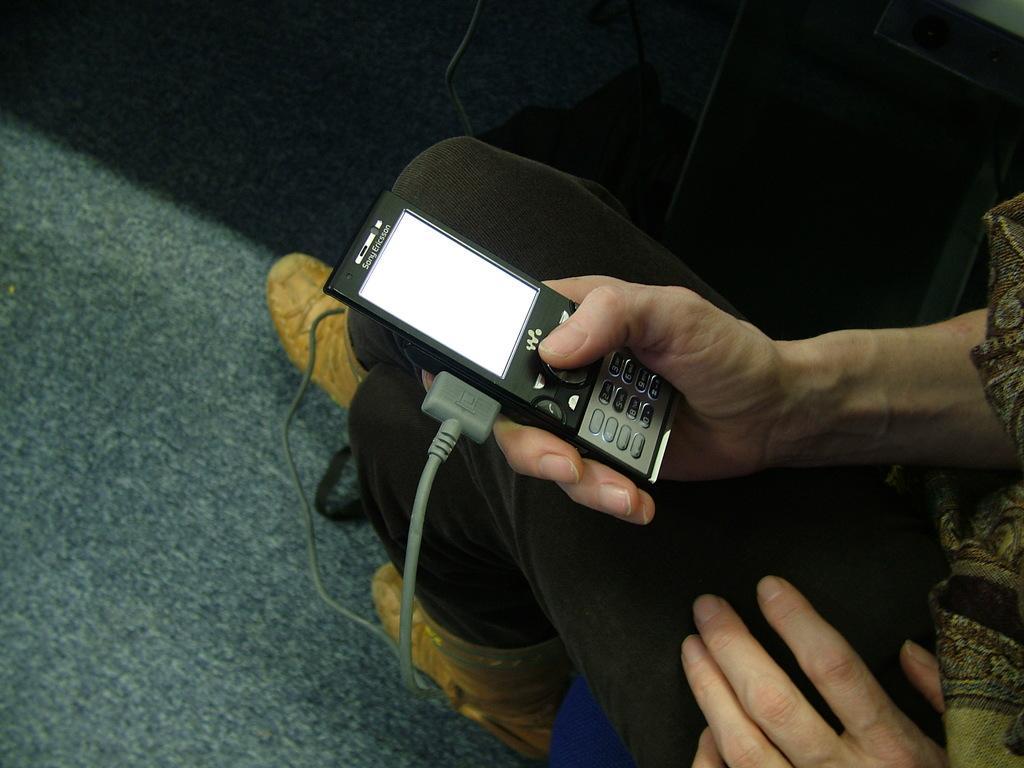Describe this image in one or two sentences. In the image we can see a person wearing clothes and shoes and the person is holding a gadget in hand. Here we can see cable wire and a floor. 